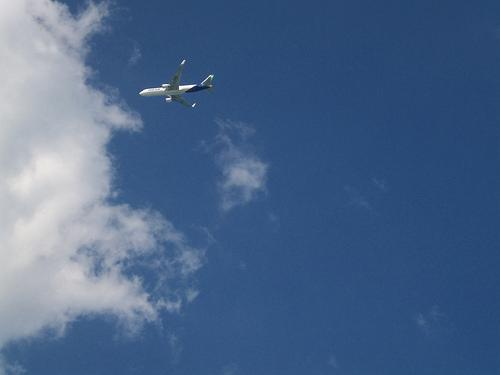Describe the airplane's appearance, the color of the sky, and the presence of clouds in the image. A sleek white airplane with blue accents is set against a deep blue sky filled with both fluffy and wispy white clouds. Provide a description of the airplane and the clouds that surround it. The white airplane with a blue tail is flying through a deep blue sky, with a large fluffy cloud below and wispy clouds behind. Provide a brief description of the scene depicted in the image. A white airplane with blue accents is flying high against a deep blue sky with a large fluffy cloud. State the main subject of the picture, the condition of the atmosphere, and the color of the clouds. The image shows a white airplane flying through a partly cloudy blue sky, with white fluffy and wispy clouds around it. Sketch a mental image of the scene in the photograph by mentioning the airplane, the sky, and the clouds. Imagine a white airplane with blue tail accents flying high against an intense blue sky, surrounded by white fluffy and wispy clouds. Briefly discuss the visual characteristics of the airplane in the image. The airplane has a sleek design, is mostly white with blue accents, and features two engines, winglets, and a blue tail. Describe the airplane and the weather visible in the image. A white airplane with blue tail is shown against an intense blue, partly cloudy sky. What is the color and position of the plane, the sky, and any other significant elements in the image? The white plane with blue accents is situated in the upper left, flying through a blue sky with a large white cloud below. Explain the main elements in this image, focusing on the plane and its features. The image presents a white airplane with a sleek, minimal design, blue tail, two engines, and winglets pointing upwards. Mention the color of the plane, the sky, and the position of the plane within the image. The plane is white with blue accents, flying against an intense blue sky in the upper left area. 